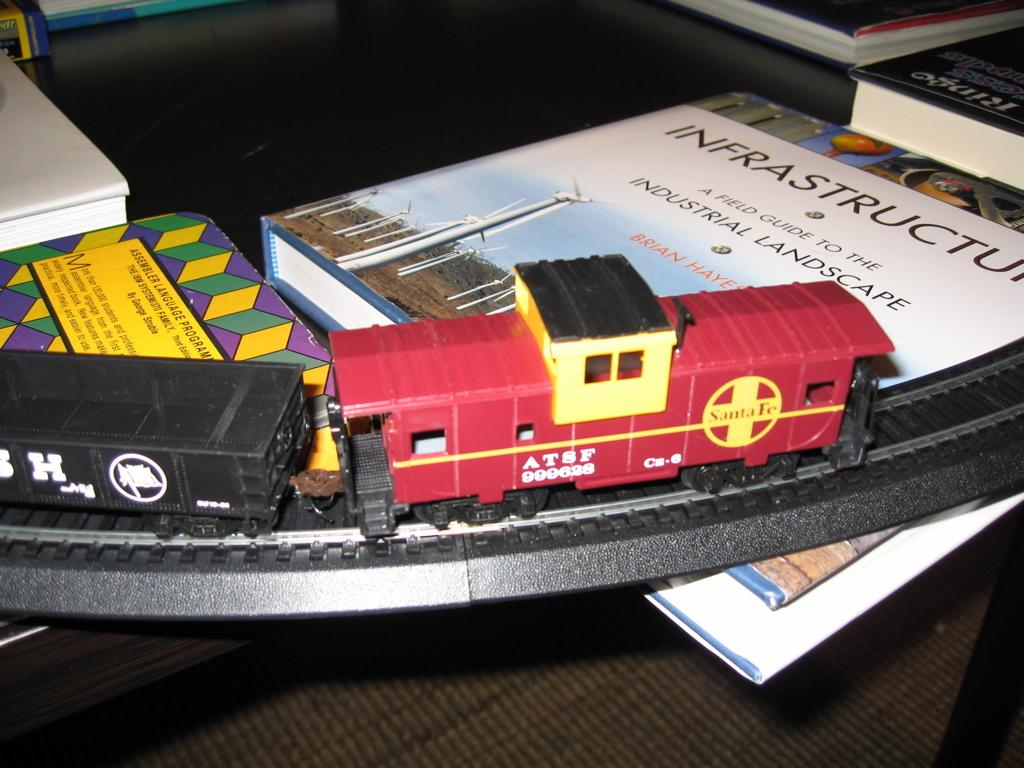Provide a one-sentence caption for the provided image. Part of a train set toy is on top of a book entitled INFRASTRUCTURE a field guide to the industrial landscape. 